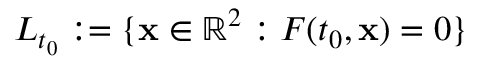Convert formula to latex. <formula><loc_0><loc_0><loc_500><loc_500>L _ { t _ { 0 } } \colon = \{ { x } \in \mathbb { R } ^ { 2 } \colon F ( t _ { 0 } , { x } ) = 0 \}</formula> 